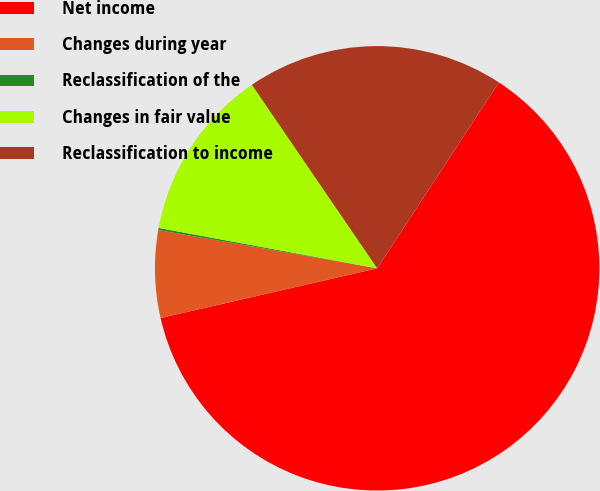<chart> <loc_0><loc_0><loc_500><loc_500><pie_chart><fcel>Net income<fcel>Changes during year<fcel>Reclassification of the<fcel>Changes in fair value<fcel>Reclassification to income<nl><fcel>62.19%<fcel>6.35%<fcel>0.15%<fcel>12.56%<fcel>18.76%<nl></chart> 